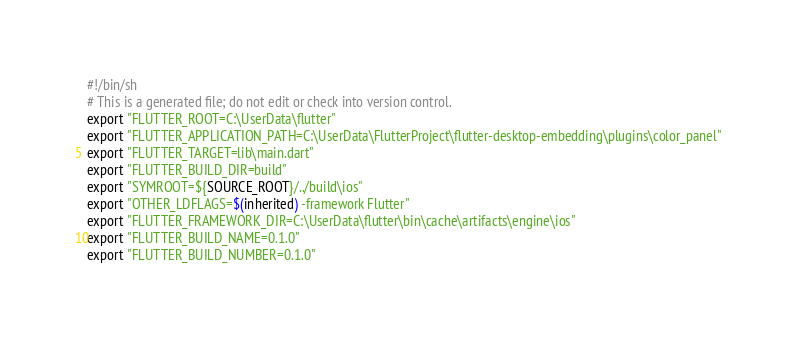Convert code to text. <code><loc_0><loc_0><loc_500><loc_500><_Bash_>#!/bin/sh
# This is a generated file; do not edit or check into version control.
export "FLUTTER_ROOT=C:\UserData\flutter"
export "FLUTTER_APPLICATION_PATH=C:\UserData\FlutterProject\flutter-desktop-embedding\plugins\color_panel"
export "FLUTTER_TARGET=lib\main.dart"
export "FLUTTER_BUILD_DIR=build"
export "SYMROOT=${SOURCE_ROOT}/../build\ios"
export "OTHER_LDFLAGS=$(inherited) -framework Flutter"
export "FLUTTER_FRAMEWORK_DIR=C:\UserData\flutter\bin\cache\artifacts\engine\ios"
export "FLUTTER_BUILD_NAME=0.1.0"
export "FLUTTER_BUILD_NUMBER=0.1.0"
</code> 